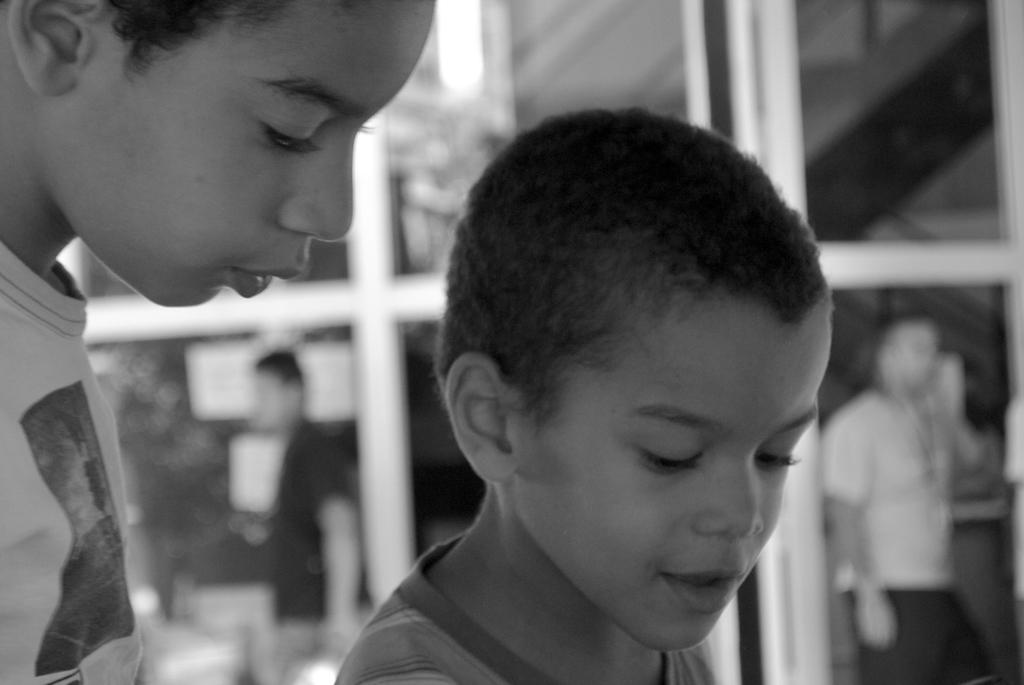Who or what can be seen in the image? There are people in the image. What is visible in the background of the image? There is a glass door in the background of the image. What type of jeans are the birds wearing in the image? There are no birds or jeans present in the image. What punishment is being given to the people in the image? There is no indication of punishment in the image; the people are simply visible. 